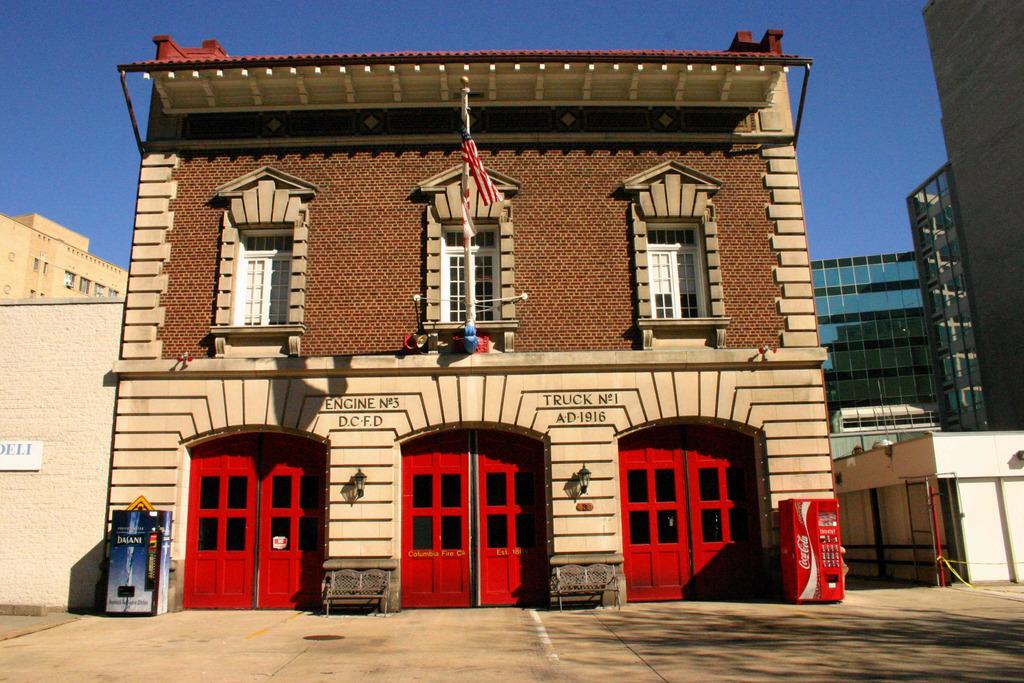Please provide a concise description of this image. In this image we can see a building with windows, doors and a flag, there is some text is written on it, in front of it there are vending machines and benches, on its side there are buildings and in the background we can see the sky. 